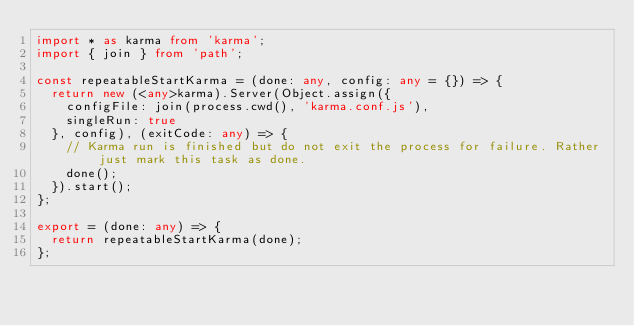<code> <loc_0><loc_0><loc_500><loc_500><_TypeScript_>import * as karma from 'karma';
import { join } from 'path';

const repeatableStartKarma = (done: any, config: any = {}) => {
  return new (<any>karma).Server(Object.assign({
    configFile: join(process.cwd(), 'karma.conf.js'),
    singleRun: true
  }, config), (exitCode: any) => {
    // Karma run is finished but do not exit the process for failure. Rather just mark this task as done.
    done();
  }).start();
};

export = (done: any) => {
  return repeatableStartKarma(done);
};
</code> 